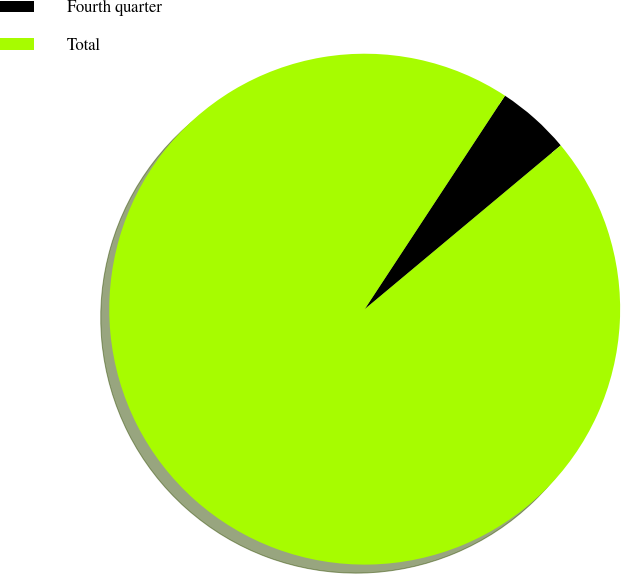Convert chart. <chart><loc_0><loc_0><loc_500><loc_500><pie_chart><fcel>Fourth quarter<fcel>Total<nl><fcel>4.67%<fcel>95.33%<nl></chart> 